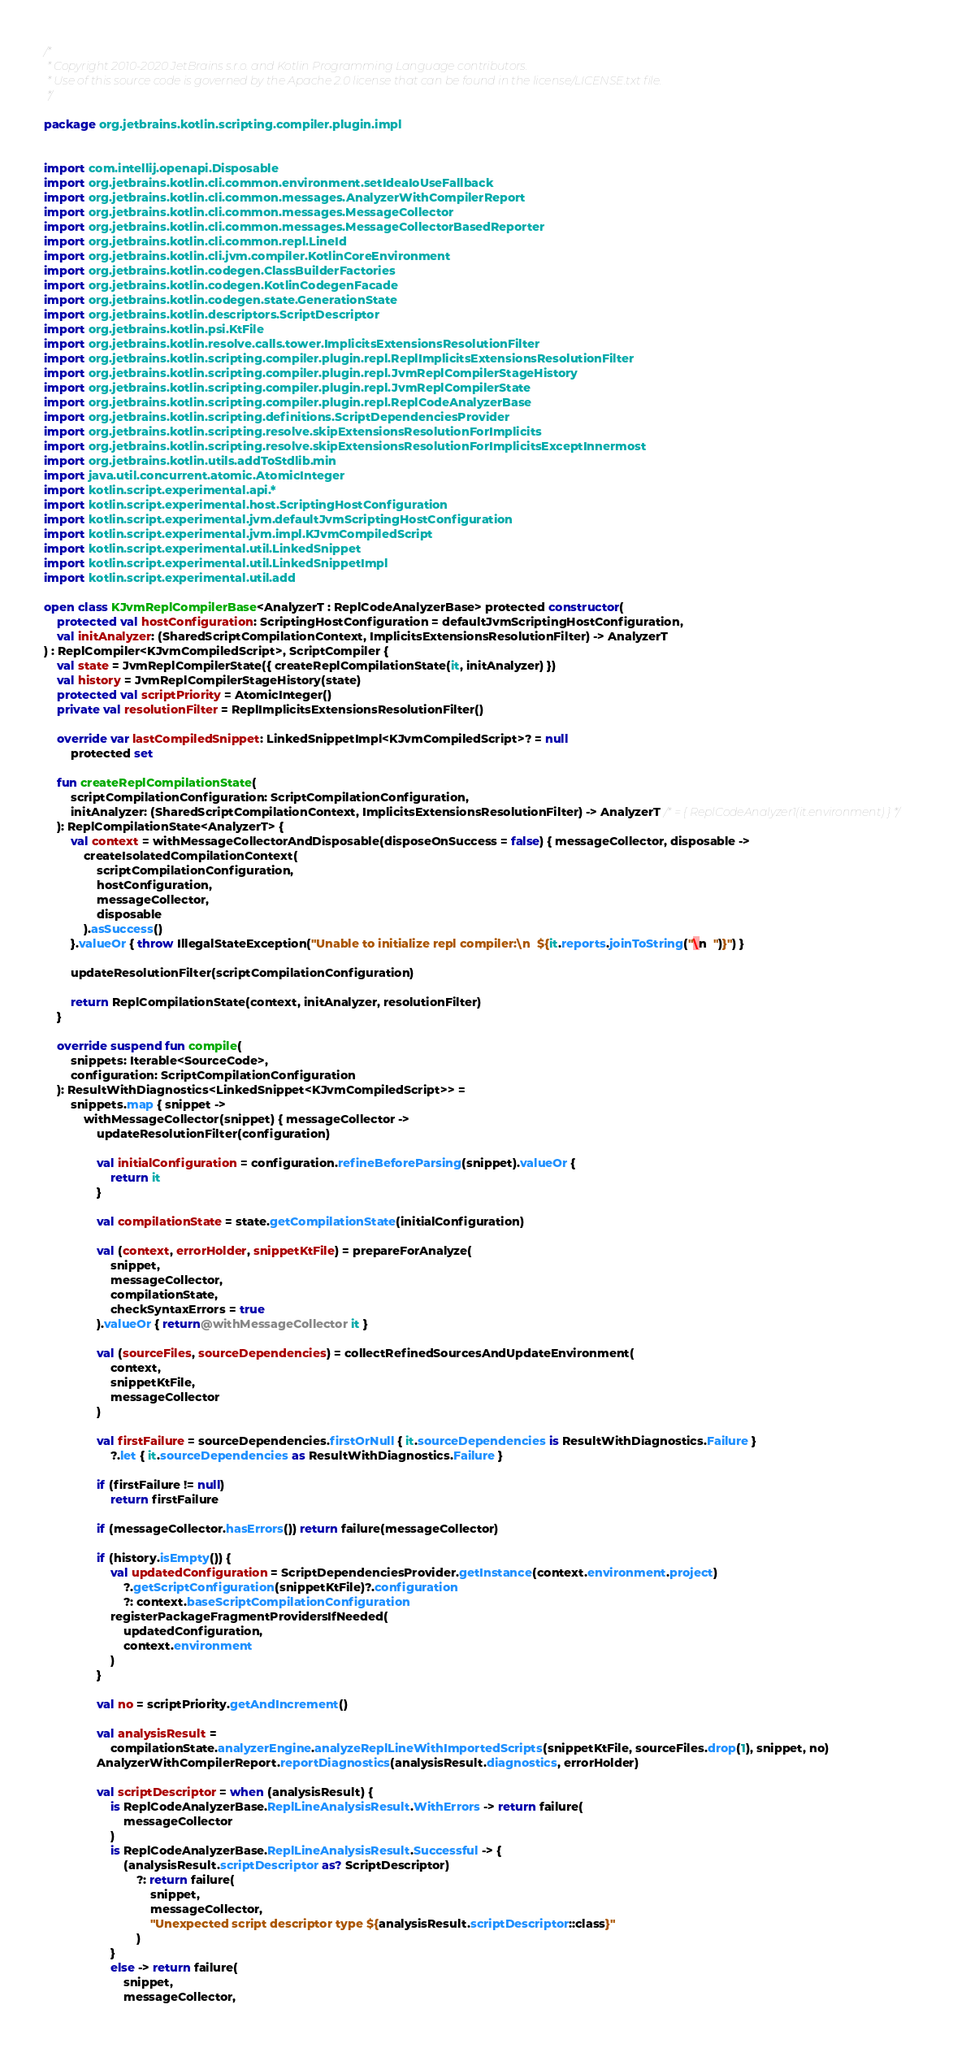Convert code to text. <code><loc_0><loc_0><loc_500><loc_500><_Kotlin_>/*
 * Copyright 2010-2020 JetBrains s.r.o. and Kotlin Programming Language contributors.
 * Use of this source code is governed by the Apache 2.0 license that can be found in the license/LICENSE.txt file.
 */

package org.jetbrains.kotlin.scripting.compiler.plugin.impl


import com.intellij.openapi.Disposable
import org.jetbrains.kotlin.cli.common.environment.setIdeaIoUseFallback
import org.jetbrains.kotlin.cli.common.messages.AnalyzerWithCompilerReport
import org.jetbrains.kotlin.cli.common.messages.MessageCollector
import org.jetbrains.kotlin.cli.common.messages.MessageCollectorBasedReporter
import org.jetbrains.kotlin.cli.common.repl.LineId
import org.jetbrains.kotlin.cli.jvm.compiler.KotlinCoreEnvironment
import org.jetbrains.kotlin.codegen.ClassBuilderFactories
import org.jetbrains.kotlin.codegen.KotlinCodegenFacade
import org.jetbrains.kotlin.codegen.state.GenerationState
import org.jetbrains.kotlin.descriptors.ScriptDescriptor
import org.jetbrains.kotlin.psi.KtFile
import org.jetbrains.kotlin.resolve.calls.tower.ImplicitsExtensionsResolutionFilter
import org.jetbrains.kotlin.scripting.compiler.plugin.repl.ReplImplicitsExtensionsResolutionFilter
import org.jetbrains.kotlin.scripting.compiler.plugin.repl.JvmReplCompilerStageHistory
import org.jetbrains.kotlin.scripting.compiler.plugin.repl.JvmReplCompilerState
import org.jetbrains.kotlin.scripting.compiler.plugin.repl.ReplCodeAnalyzerBase
import org.jetbrains.kotlin.scripting.definitions.ScriptDependenciesProvider
import org.jetbrains.kotlin.scripting.resolve.skipExtensionsResolutionForImplicits
import org.jetbrains.kotlin.scripting.resolve.skipExtensionsResolutionForImplicitsExceptInnermost
import org.jetbrains.kotlin.utils.addToStdlib.min
import java.util.concurrent.atomic.AtomicInteger
import kotlin.script.experimental.api.*
import kotlin.script.experimental.host.ScriptingHostConfiguration
import kotlin.script.experimental.jvm.defaultJvmScriptingHostConfiguration
import kotlin.script.experimental.jvm.impl.KJvmCompiledScript
import kotlin.script.experimental.util.LinkedSnippet
import kotlin.script.experimental.util.LinkedSnippetImpl
import kotlin.script.experimental.util.add

open class KJvmReplCompilerBase<AnalyzerT : ReplCodeAnalyzerBase> protected constructor(
    protected val hostConfiguration: ScriptingHostConfiguration = defaultJvmScriptingHostConfiguration,
    val initAnalyzer: (SharedScriptCompilationContext, ImplicitsExtensionsResolutionFilter) -> AnalyzerT
) : ReplCompiler<KJvmCompiledScript>, ScriptCompiler {
    val state = JvmReplCompilerState({ createReplCompilationState(it, initAnalyzer) })
    val history = JvmReplCompilerStageHistory(state)
    protected val scriptPriority = AtomicInteger()
    private val resolutionFilter = ReplImplicitsExtensionsResolutionFilter()

    override var lastCompiledSnippet: LinkedSnippetImpl<KJvmCompiledScript>? = null
        protected set

    fun createReplCompilationState(
        scriptCompilationConfiguration: ScriptCompilationConfiguration,
        initAnalyzer: (SharedScriptCompilationContext, ImplicitsExtensionsResolutionFilter) -> AnalyzerT /* = { ReplCodeAnalyzer1(it.environment) } */
    ): ReplCompilationState<AnalyzerT> {
        val context = withMessageCollectorAndDisposable(disposeOnSuccess = false) { messageCollector, disposable ->
            createIsolatedCompilationContext(
                scriptCompilationConfiguration,
                hostConfiguration,
                messageCollector,
                disposable
            ).asSuccess()
        }.valueOr { throw IllegalStateException("Unable to initialize repl compiler:\n  ${it.reports.joinToString("\n  ")}") }

        updateResolutionFilter(scriptCompilationConfiguration)

        return ReplCompilationState(context, initAnalyzer, resolutionFilter)
    }

    override suspend fun compile(
        snippets: Iterable<SourceCode>,
        configuration: ScriptCompilationConfiguration
    ): ResultWithDiagnostics<LinkedSnippet<KJvmCompiledScript>> =
        snippets.map { snippet ->
            withMessageCollector(snippet) { messageCollector ->
                updateResolutionFilter(configuration)

                val initialConfiguration = configuration.refineBeforeParsing(snippet).valueOr {
                    return it
                }

                val compilationState = state.getCompilationState(initialConfiguration)

                val (context, errorHolder, snippetKtFile) = prepareForAnalyze(
                    snippet,
                    messageCollector,
                    compilationState,
                    checkSyntaxErrors = true
                ).valueOr { return@withMessageCollector it }

                val (sourceFiles, sourceDependencies) = collectRefinedSourcesAndUpdateEnvironment(
                    context,
                    snippetKtFile,
                    messageCollector
                )

                val firstFailure = sourceDependencies.firstOrNull { it.sourceDependencies is ResultWithDiagnostics.Failure }
                    ?.let { it.sourceDependencies as ResultWithDiagnostics.Failure }

                if (firstFailure != null)
                    return firstFailure

                if (messageCollector.hasErrors()) return failure(messageCollector)

                if (history.isEmpty()) {
                    val updatedConfiguration = ScriptDependenciesProvider.getInstance(context.environment.project)
                        ?.getScriptConfiguration(snippetKtFile)?.configuration
                        ?: context.baseScriptCompilationConfiguration
                    registerPackageFragmentProvidersIfNeeded(
                        updatedConfiguration,
                        context.environment
                    )
                }

                val no = scriptPriority.getAndIncrement()

                val analysisResult =
                    compilationState.analyzerEngine.analyzeReplLineWithImportedScripts(snippetKtFile, sourceFiles.drop(1), snippet, no)
                AnalyzerWithCompilerReport.reportDiagnostics(analysisResult.diagnostics, errorHolder)

                val scriptDescriptor = when (analysisResult) {
                    is ReplCodeAnalyzerBase.ReplLineAnalysisResult.WithErrors -> return failure(
                        messageCollector
                    )
                    is ReplCodeAnalyzerBase.ReplLineAnalysisResult.Successful -> {
                        (analysisResult.scriptDescriptor as? ScriptDescriptor)
                            ?: return failure(
                                snippet,
                                messageCollector,
                                "Unexpected script descriptor type ${analysisResult.scriptDescriptor::class}"
                            )
                    }
                    else -> return failure(
                        snippet,
                        messageCollector,</code> 